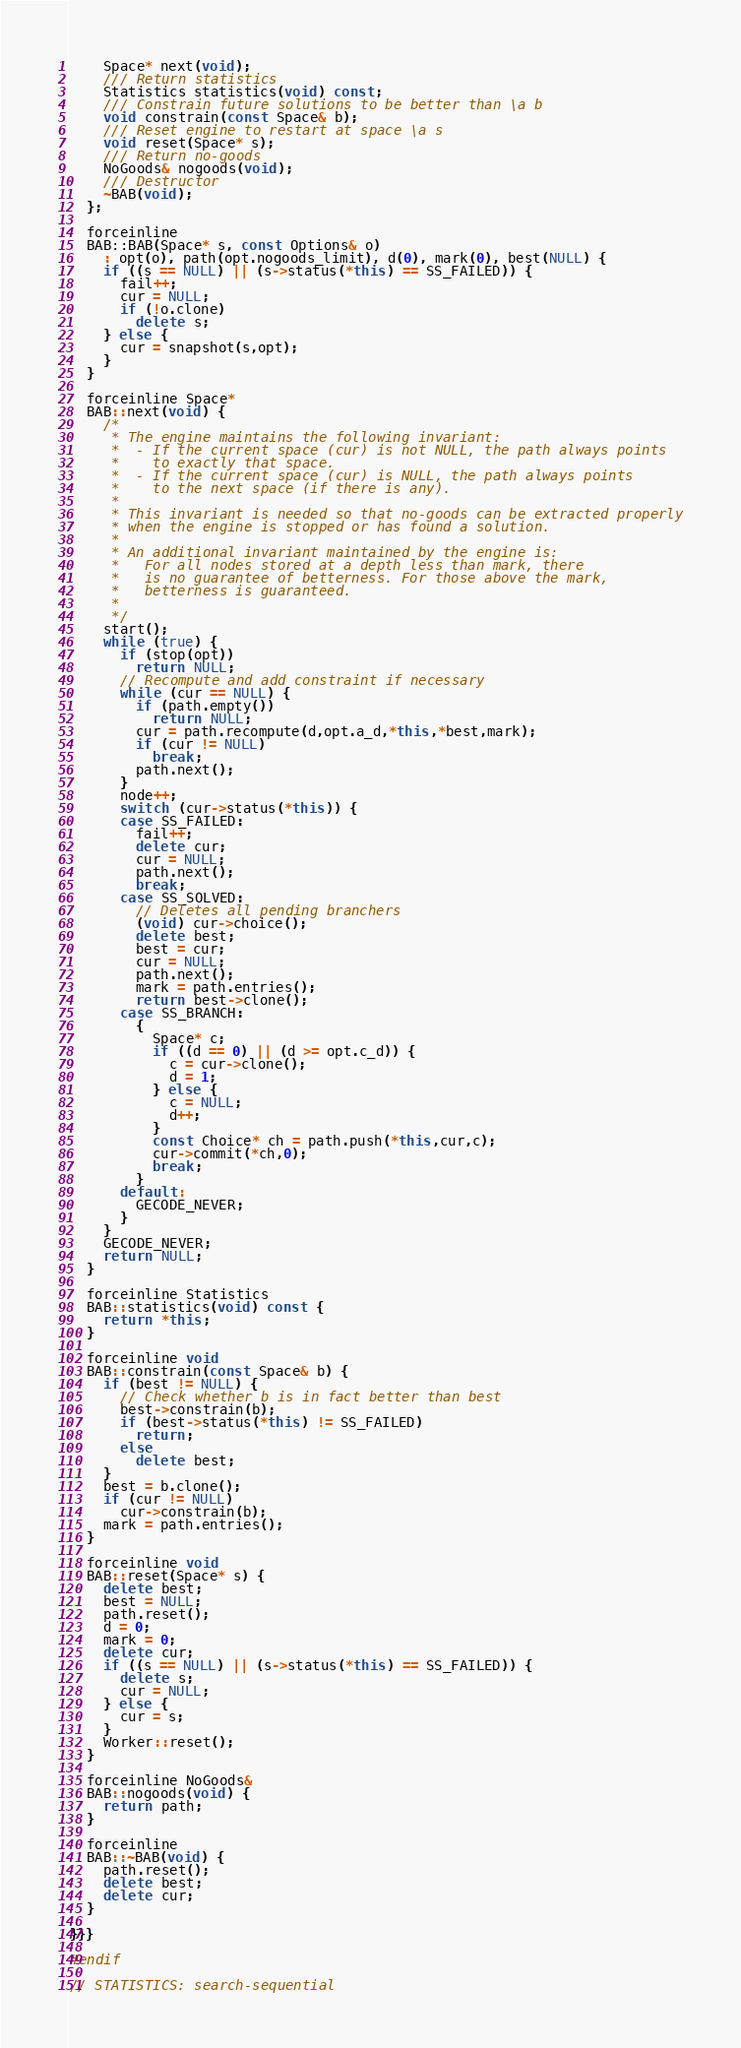Convert code to text. <code><loc_0><loc_0><loc_500><loc_500><_C++_>    Space* next(void);
    /// Return statistics
    Statistics statistics(void) const;
    /// Constrain future solutions to be better than \a b
    void constrain(const Space& b);
    /// Reset engine to restart at space \a s
    void reset(Space* s);
    /// Return no-goods
    NoGoods& nogoods(void);
    /// Destructor
    ~BAB(void);
  };

  forceinline
  BAB::BAB(Space* s, const Options& o)
    : opt(o), path(opt.nogoods_limit), d(0), mark(0), best(NULL) {
    if ((s == NULL) || (s->status(*this) == SS_FAILED)) {
      fail++;
      cur = NULL;
      if (!o.clone)
        delete s;
    } else {
      cur = snapshot(s,opt);
    }
  }

  forceinline Space*
  BAB::next(void) {
    /*
     * The engine maintains the following invariant:
     *  - If the current space (cur) is not NULL, the path always points
     *    to exactly that space.
     *  - If the current space (cur) is NULL, the path always points
     *    to the next space (if there is any).
     *
     * This invariant is needed so that no-goods can be extracted properly
     * when the engine is stopped or has found a solution.
     *
     * An additional invariant maintained by the engine is:
     *   For all nodes stored at a depth less than mark, there
     *   is no guarantee of betterness. For those above the mark,
     *   betterness is guaranteed.
     *
     */
    start();
    while (true) {
      if (stop(opt))
        return NULL;
      // Recompute and add constraint if necessary
      while (cur == NULL) {
        if (path.empty())
          return NULL;
        cur = path.recompute(d,opt.a_d,*this,*best,mark);
        if (cur != NULL)
          break;
        path.next();
      }
      node++;
      switch (cur->status(*this)) {
      case SS_FAILED:
        fail++;
        delete cur;
        cur = NULL;
        path.next();
        break;
      case SS_SOLVED:
        // Deletes all pending branchers
        (void) cur->choice();
        delete best;
        best = cur;
        cur = NULL;
        path.next();
        mark = path.entries();
        return best->clone();
      case SS_BRANCH:
        {
          Space* c;
          if ((d == 0) || (d >= opt.c_d)) {
            c = cur->clone();
            d = 1;
          } else {
            c = NULL;
            d++;
          }
          const Choice* ch = path.push(*this,cur,c);
          cur->commit(*ch,0);
          break;
        }
      default:
        GECODE_NEVER;
      }
    }
    GECODE_NEVER;
    return NULL;
  }

  forceinline Statistics
  BAB::statistics(void) const {
    return *this;
  }

  forceinline void
  BAB::constrain(const Space& b) {
    if (best != NULL) {
      // Check whether b is in fact better than best
      best->constrain(b);
      if (best->status(*this) != SS_FAILED)
        return;
      else
        delete best;
    }
    best = b.clone();
    if (cur != NULL)
      cur->constrain(b);
    mark = path.entries();
  }

  forceinline void
  BAB::reset(Space* s) {
    delete best;
    best = NULL;
    path.reset();
    d = 0;
    mark = 0;
    delete cur;
    if ((s == NULL) || (s->status(*this) == SS_FAILED)) {
      delete s;
      cur = NULL;
    } else {
      cur = s;
    }
    Worker::reset();
  }

  forceinline NoGoods&
  BAB::nogoods(void) {
    return path;
  }

  forceinline
  BAB::~BAB(void) {
    path.reset();
    delete best;
    delete cur;
  }

}}}

#endif

// STATISTICS: search-sequential
</code> 